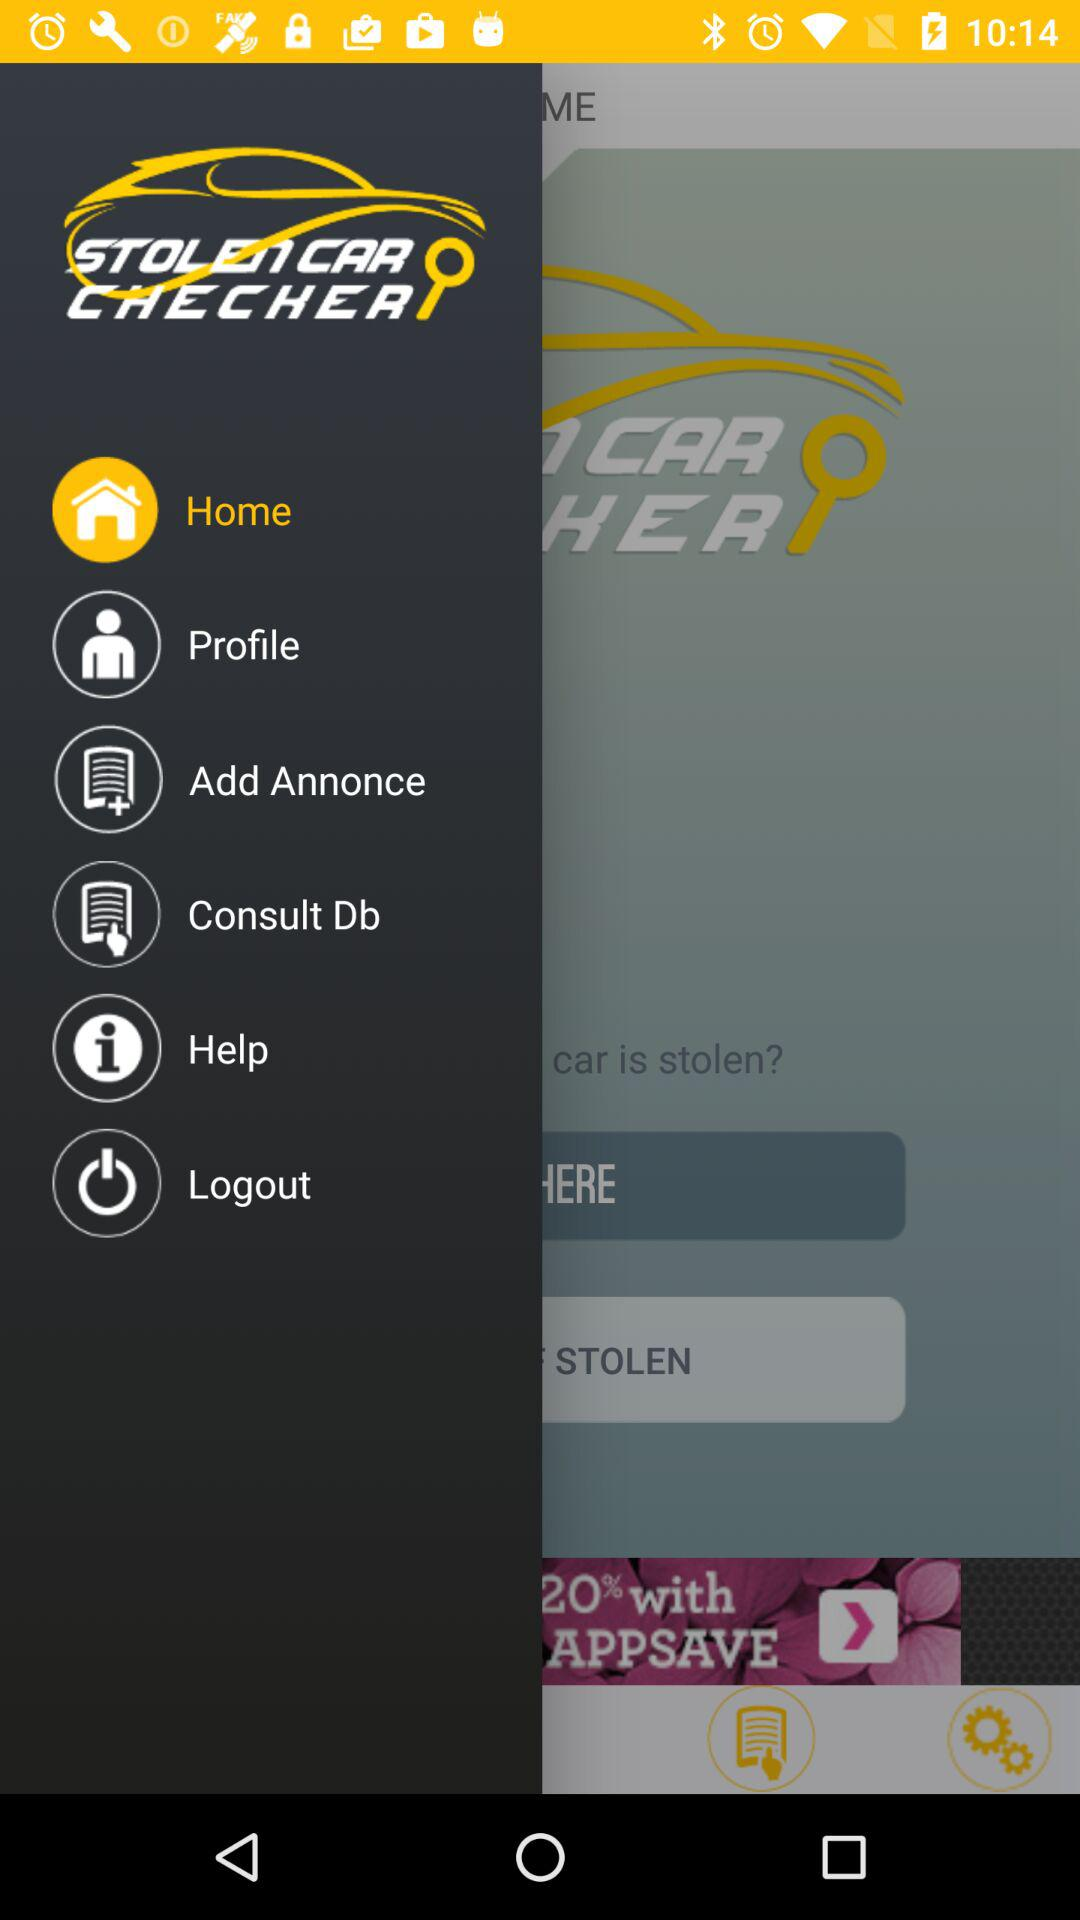What is the user's name?
When the provided information is insufficient, respond with <no answer>. <no answer> 